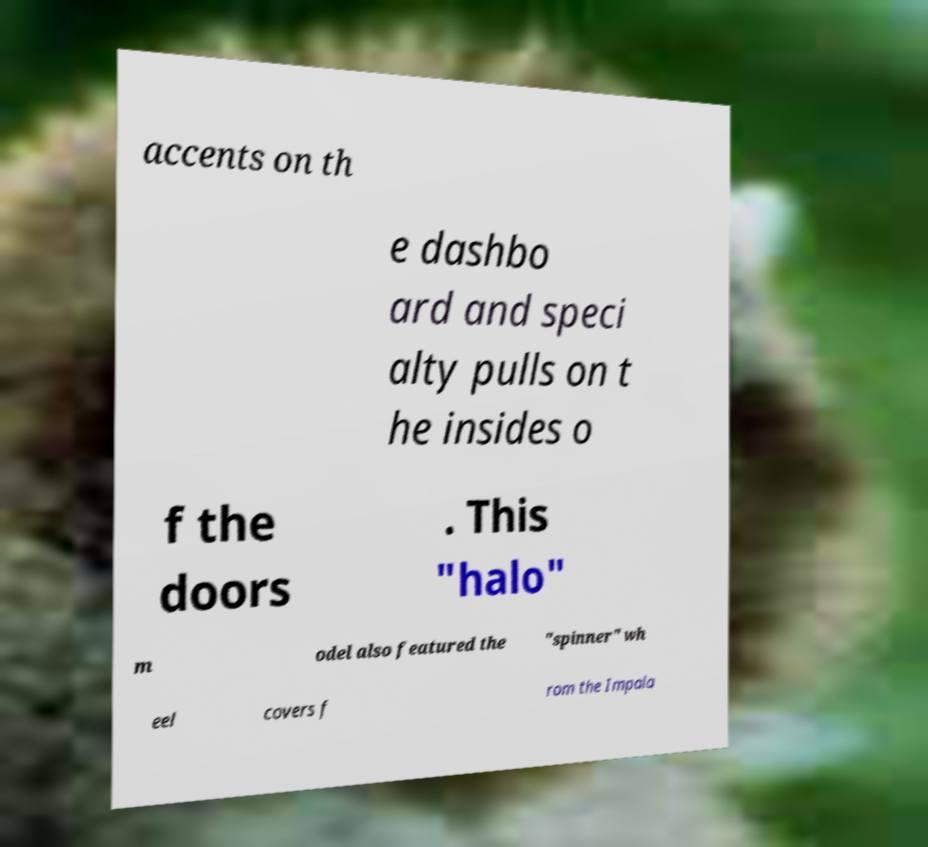Please identify and transcribe the text found in this image. accents on th e dashbo ard and speci alty pulls on t he insides o f the doors . This "halo" m odel also featured the "spinner" wh eel covers f rom the Impala 